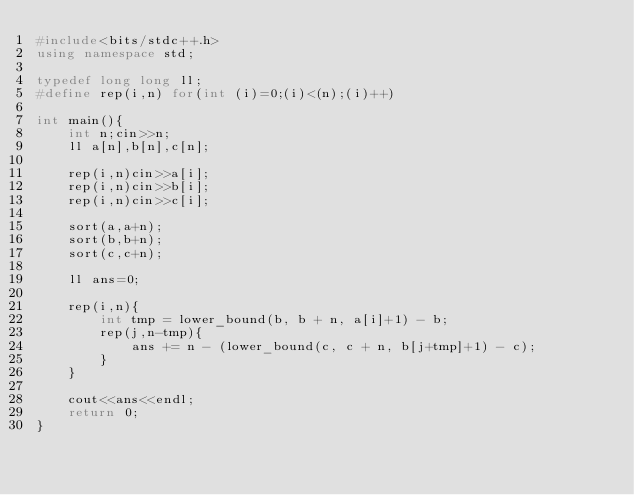Convert code to text. <code><loc_0><loc_0><loc_500><loc_500><_C++_>#include<bits/stdc++.h>
using namespace std;

typedef long long ll;
#define rep(i,n) for(int (i)=0;(i)<(n);(i)++)

int main(){
    int n;cin>>n;
    ll a[n],b[n],c[n];

    rep(i,n)cin>>a[i];
    rep(i,n)cin>>b[i];
    rep(i,n)cin>>c[i];

    sort(a,a+n);
    sort(b,b+n);
    sort(c,c+n);
    
    ll ans=0;
    
    rep(i,n){
        int tmp = lower_bound(b, b + n, a[i]+1) - b;
        rep(j,n-tmp){
            ans += n - (lower_bound(c, c + n, b[j+tmp]+1) - c);
        }
    }
    
    cout<<ans<<endl;
    return 0;
}</code> 